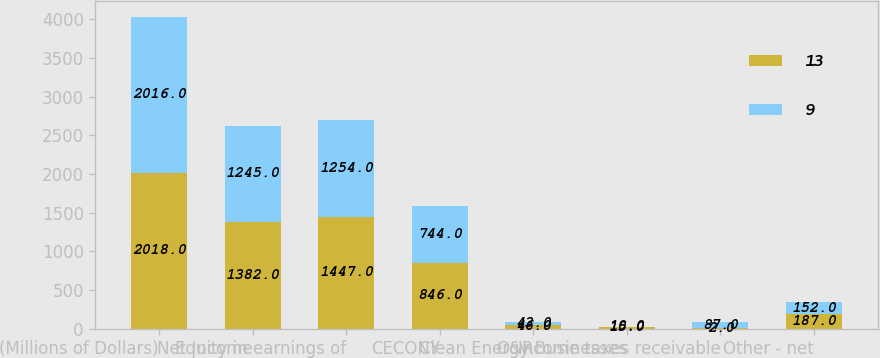<chart> <loc_0><loc_0><loc_500><loc_500><stacked_bar_chart><ecel><fcel>(Millions of Dollars)<fcel>Net Income<fcel>Equity in earnings of<fcel>CECONY<fcel>O&R<fcel>Clean Energy Businesses<fcel>Income taxes receivable<fcel>Other - net<nl><fcel>13<fcel>2018<fcel>1382<fcel>1447<fcel>846<fcel>46<fcel>15<fcel>2<fcel>187<nl><fcel>9<fcel>2016<fcel>1245<fcel>1254<fcel>744<fcel>43<fcel>10<fcel>87<fcel>152<nl></chart> 